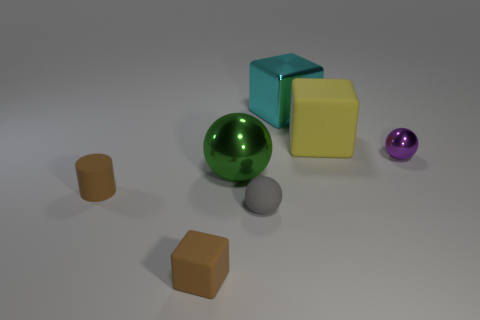Subtract all purple spheres. How many spheres are left? 2 Add 1 small purple metal cylinders. How many objects exist? 8 Subtract all brown blocks. How many blocks are left? 2 Subtract all cylinders. How many objects are left? 6 Subtract 1 balls. How many balls are left? 2 Subtract all cyan cylinders. Subtract all brown spheres. How many cylinders are left? 1 Subtract all purple spheres. How many gray cylinders are left? 0 Subtract all blue cylinders. Subtract all brown things. How many objects are left? 5 Add 3 big yellow blocks. How many big yellow blocks are left? 4 Add 7 purple metallic spheres. How many purple metallic spheres exist? 8 